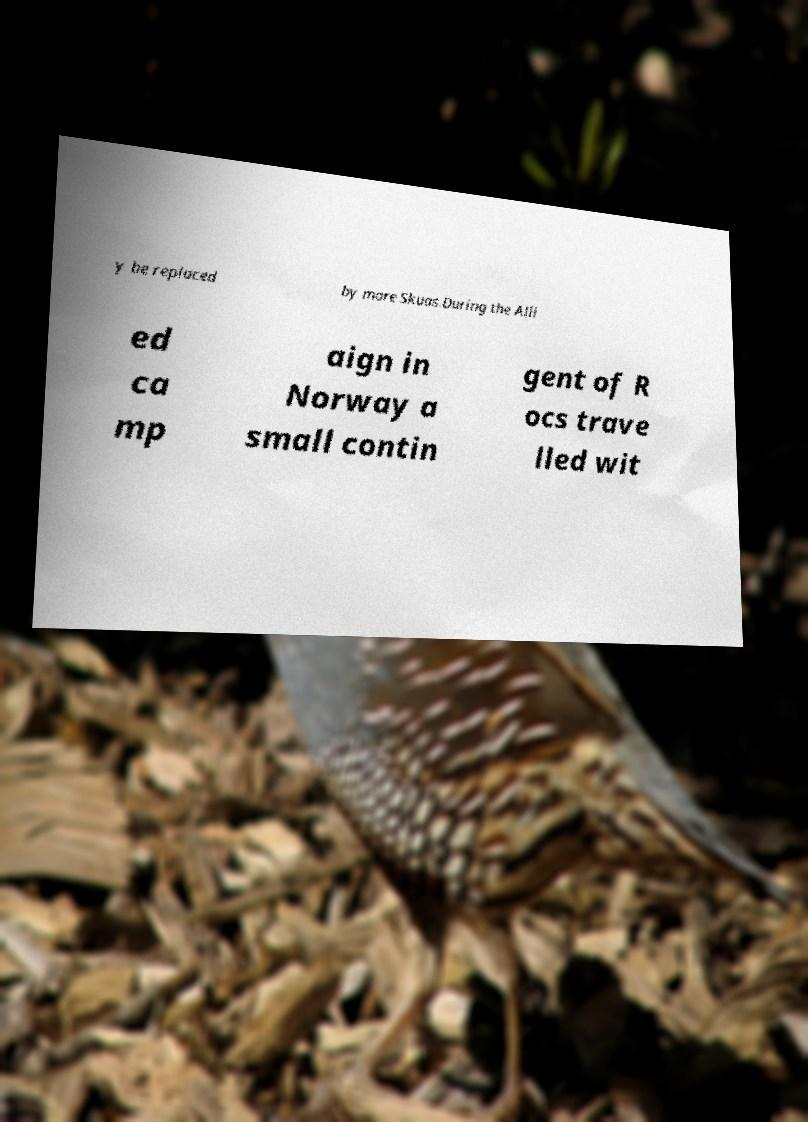Could you extract and type out the text from this image? y be replaced by more Skuas.During the Alli ed ca mp aign in Norway a small contin gent of R ocs trave lled wit 